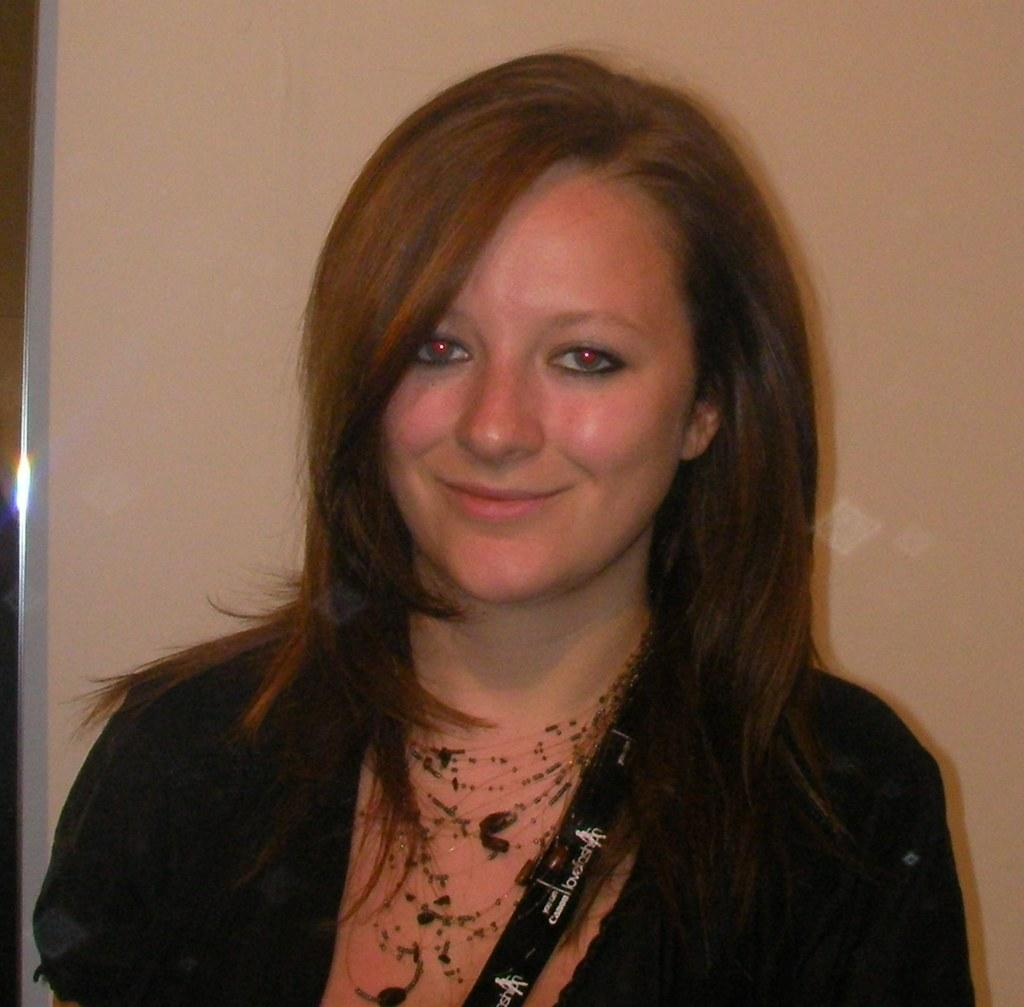Where was the image taken? The image is taken indoors. What can be seen in the background of the image? There is a wall in the background of the image. Who is the main subject in the image? There is a woman in the middle of the image. What is the woman's facial expression? The woman has a smiling face. How many accounts does the woman have in the image? There is no mention of accounts in the image, as it features a woman with a smiling face indoors. 